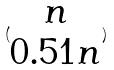Convert formula to latex. <formula><loc_0><loc_0><loc_500><loc_500>( \begin{matrix} n \\ 0 . 5 1 n \end{matrix} )</formula> 